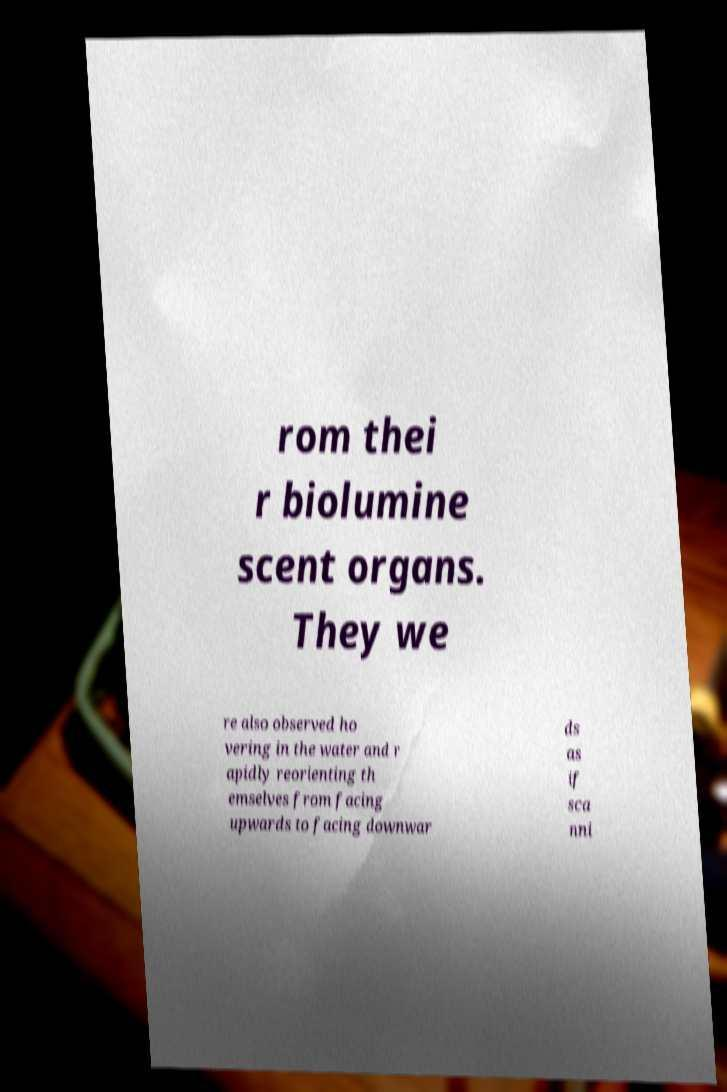I need the written content from this picture converted into text. Can you do that? rom thei r biolumine scent organs. They we re also observed ho vering in the water and r apidly reorienting th emselves from facing upwards to facing downwar ds as if sca nni 